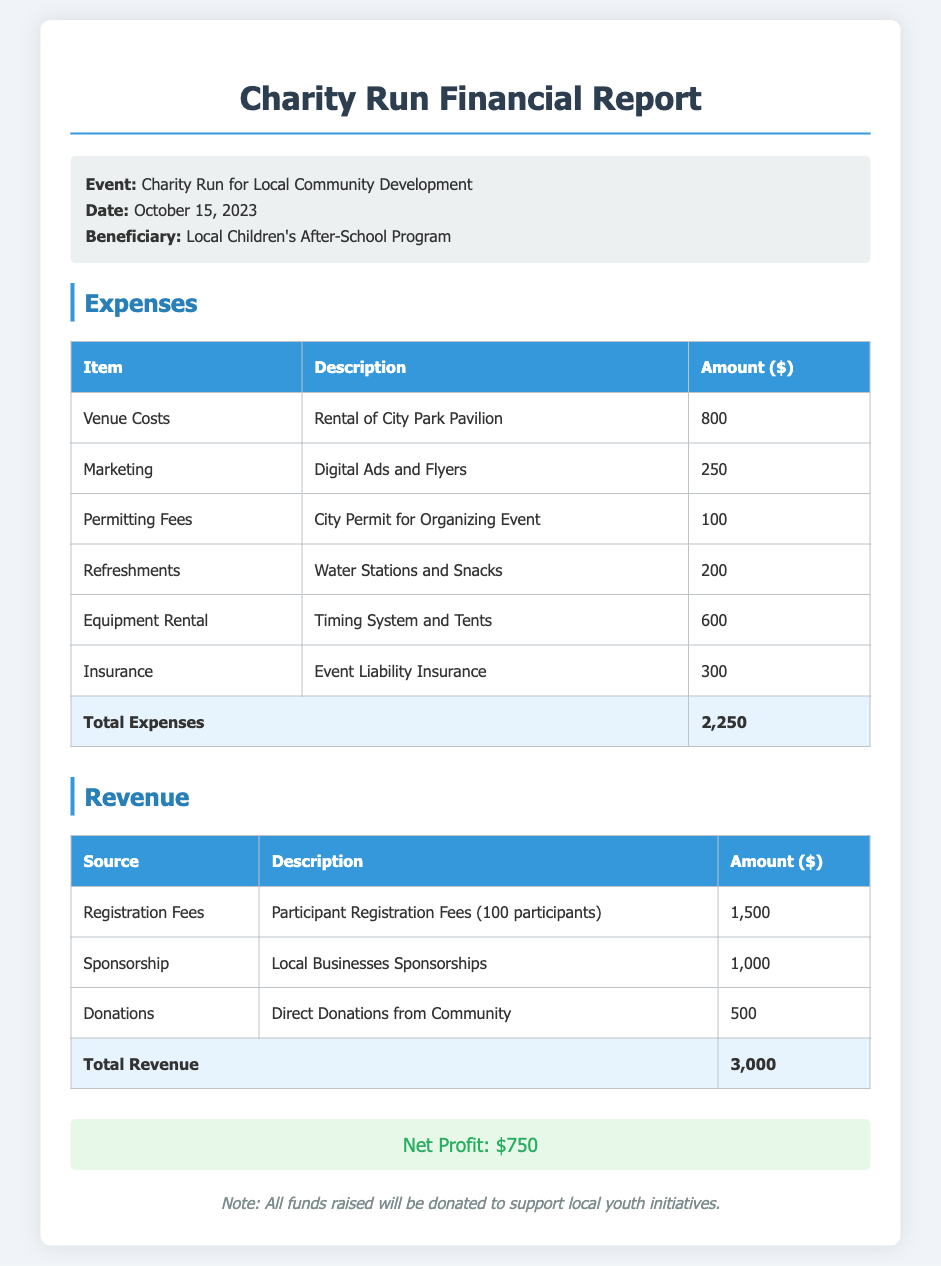What is the event name? The name of the event is specified in the document as "Charity Run for Local Community Development."
Answer: Charity Run for Local Community Development What is the net profit? The net profit is calculated from the total revenue minus total expenses, which is presented in the document as $750.
Answer: $750 How much was spent on marketing? The document lists the amount spent on marketing, specifically for digital ads and flyers, which is $250.
Answer: $250 What was the total revenue? The total revenue is provided in the document as the sum of all revenue sources, which amounts to $3000.
Answer: $3000 How much was raised from donations? The specific amount raised from direct donations from the community is detailed in the revenue section as $500.
Answer: $500 How many participants registered? The document indicates that the participant registration fees were collected from 100 participants, which is stated directly.
Answer: 100 participants What is the date of the event? The date of the charity run is specified in the document as October 15, 2023.
Answer: October 15, 2023 What is the amount spent on venue costs? The document states that the costs for renting the City Park Pavilion were $800.
Answer: $800 What is the total amount of expenses? The total expenses are computed by summing all expense items, which is given as $2250 in the document.
Answer: $2250 